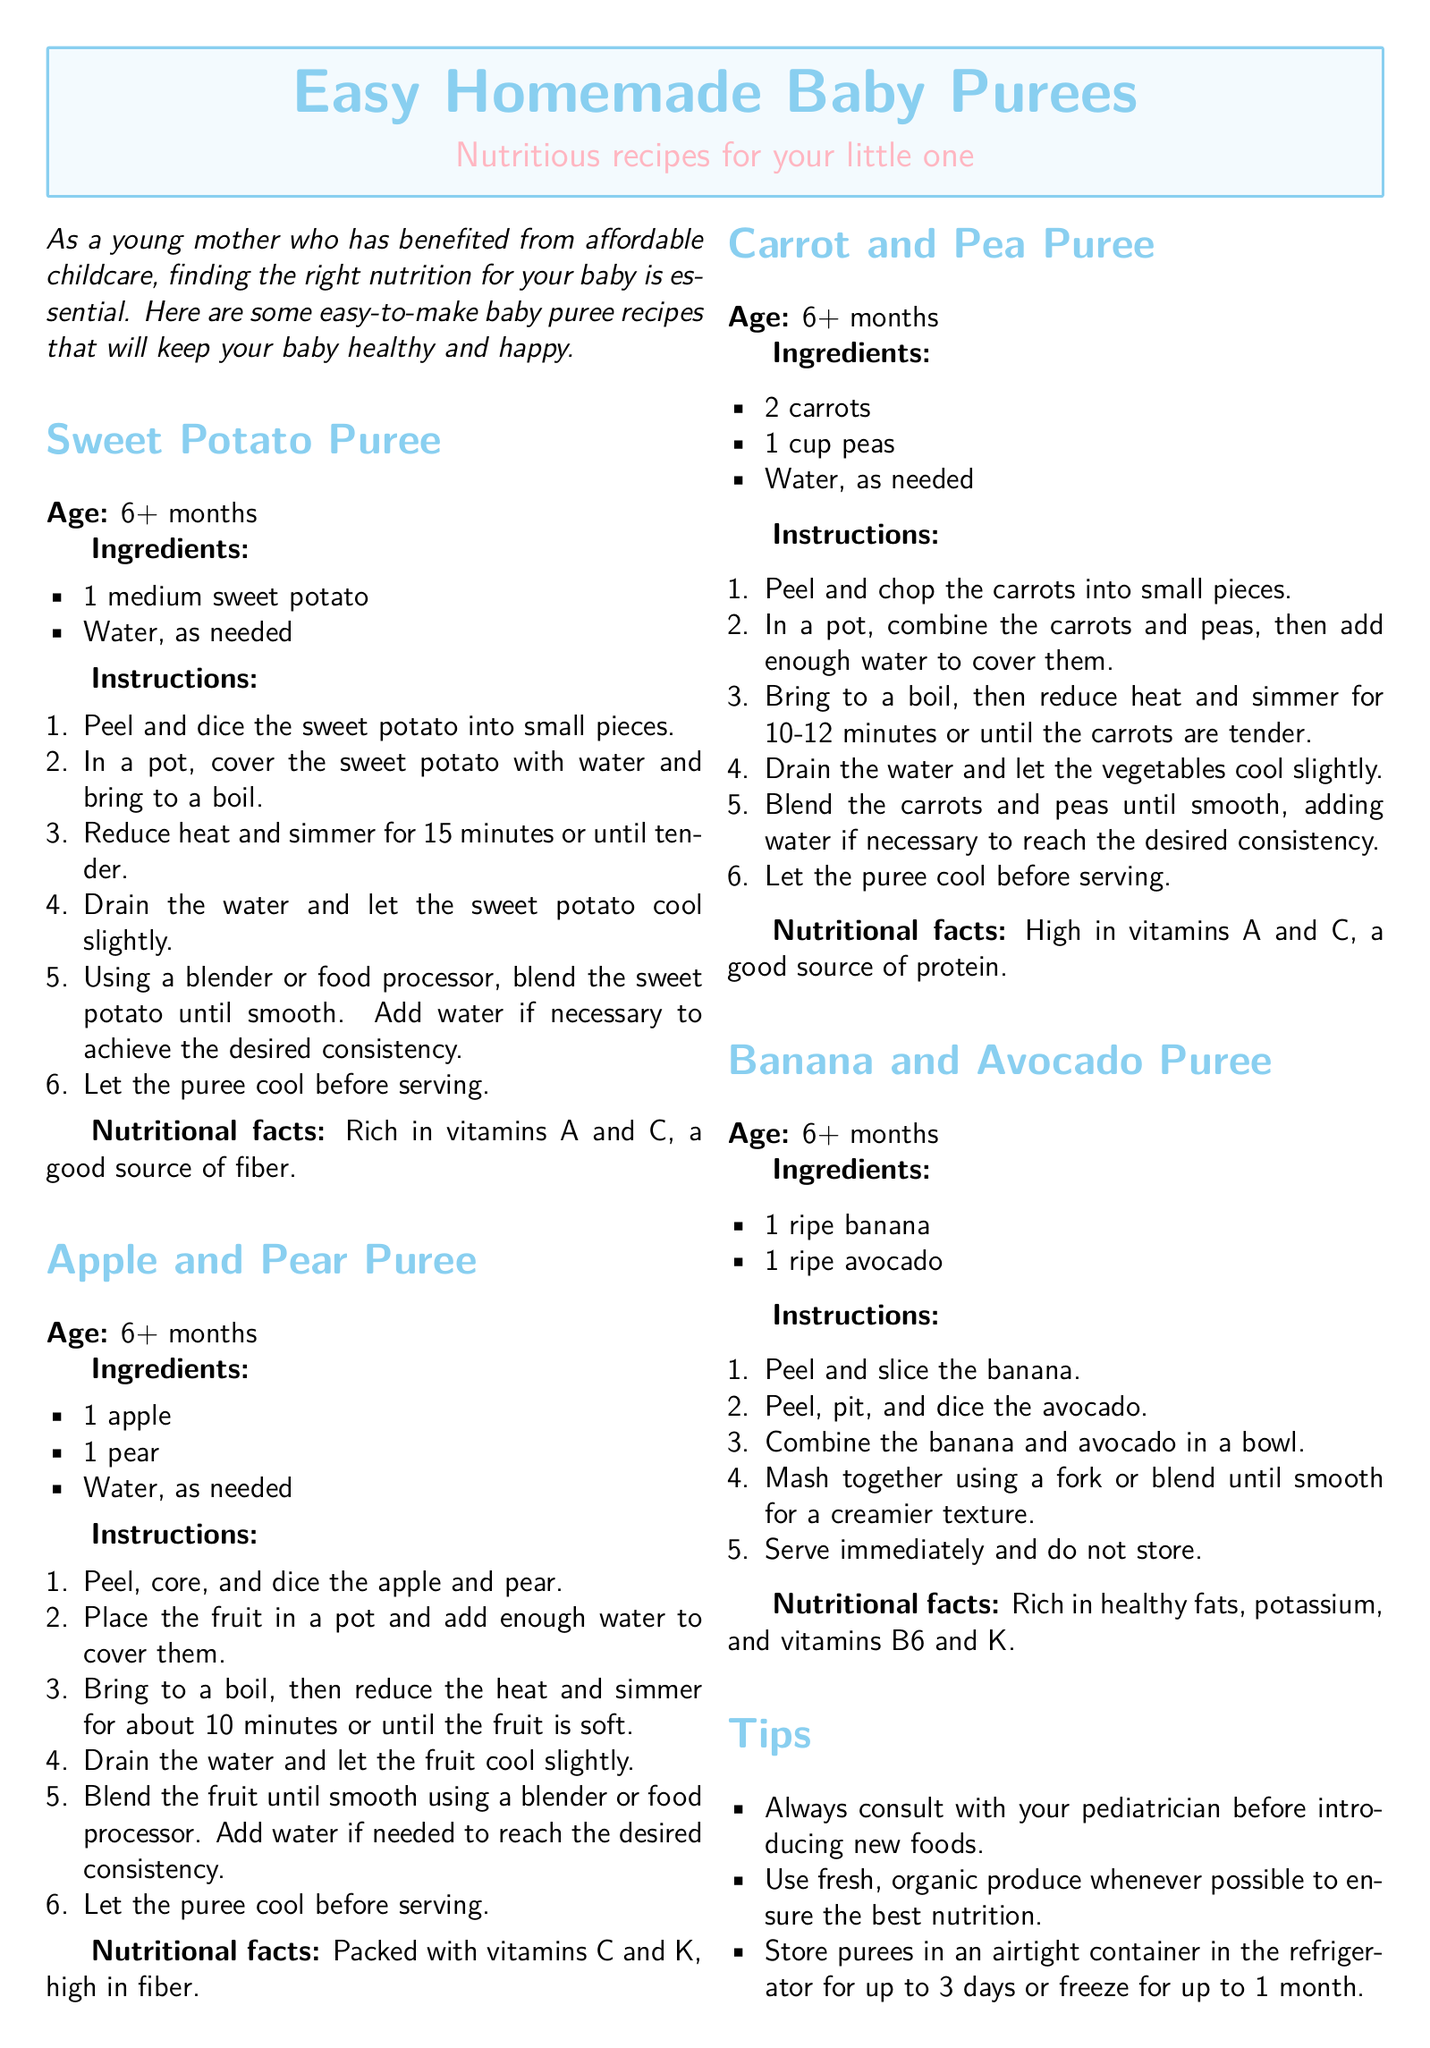What is the title of the document? The title of the document is presented prominently at the beginning, which is "Easy Homemade Baby Purees."
Answer: Easy Homemade Baby Purees At what age can babies start consuming Sweet Potato Puree? The document specifies that Sweet Potato Puree is suitable for babies aged 6+ months.
Answer: 6+ months What is one nutritional benefit of Apple and Pear Puree? The document mentions that Apple and Pear Puree is packed with vitamins C and K and high in fiber.
Answer: Vitamins C and K How many carrots are needed for the Carrot and Pea Puree recipe? The recipe states that 2 carrots are required for the Carrot and Pea Puree.
Answer: 2 carrots What should you do with Banana and Avocado Puree after preparation? The document advises that Banana and Avocado Puree should be served immediately and not stored.
Answer: Serve immediately What is a tip mentioned in the document regarding new foods? One tip advises to always consult with your pediatrician before introducing new foods.
Answer: Consult with your pediatrician What method is suggested for making the Banana and Avocado Puree smooth? The document suggests mashing together with a fork or blending until smooth.
Answer: Mash or blend How long can purees be stored in the refrigerator? The document states that purees can be stored in the refrigerator for up to 3 days.
Answer: 3 days 